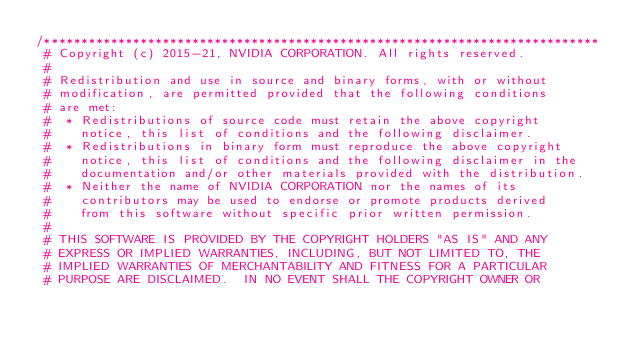<code> <loc_0><loc_0><loc_500><loc_500><_C_>/***************************************************************************
 # Copyright (c) 2015-21, NVIDIA CORPORATION. All rights reserved.
 #
 # Redistribution and use in source and binary forms, with or without
 # modification, are permitted provided that the following conditions
 # are met:
 #  * Redistributions of source code must retain the above copyright
 #    notice, this list of conditions and the following disclaimer.
 #  * Redistributions in binary form must reproduce the above copyright
 #    notice, this list of conditions and the following disclaimer in the
 #    documentation and/or other materials provided with the distribution.
 #  * Neither the name of NVIDIA CORPORATION nor the names of its
 #    contributors may be used to endorse or promote products derived
 #    from this software without specific prior written permission.
 #
 # THIS SOFTWARE IS PROVIDED BY THE COPYRIGHT HOLDERS "AS IS" AND ANY
 # EXPRESS OR IMPLIED WARRANTIES, INCLUDING, BUT NOT LIMITED TO, THE
 # IMPLIED WARRANTIES OF MERCHANTABILITY AND FITNESS FOR A PARTICULAR
 # PURPOSE ARE DISCLAIMED.  IN NO EVENT SHALL THE COPYRIGHT OWNER OR</code> 